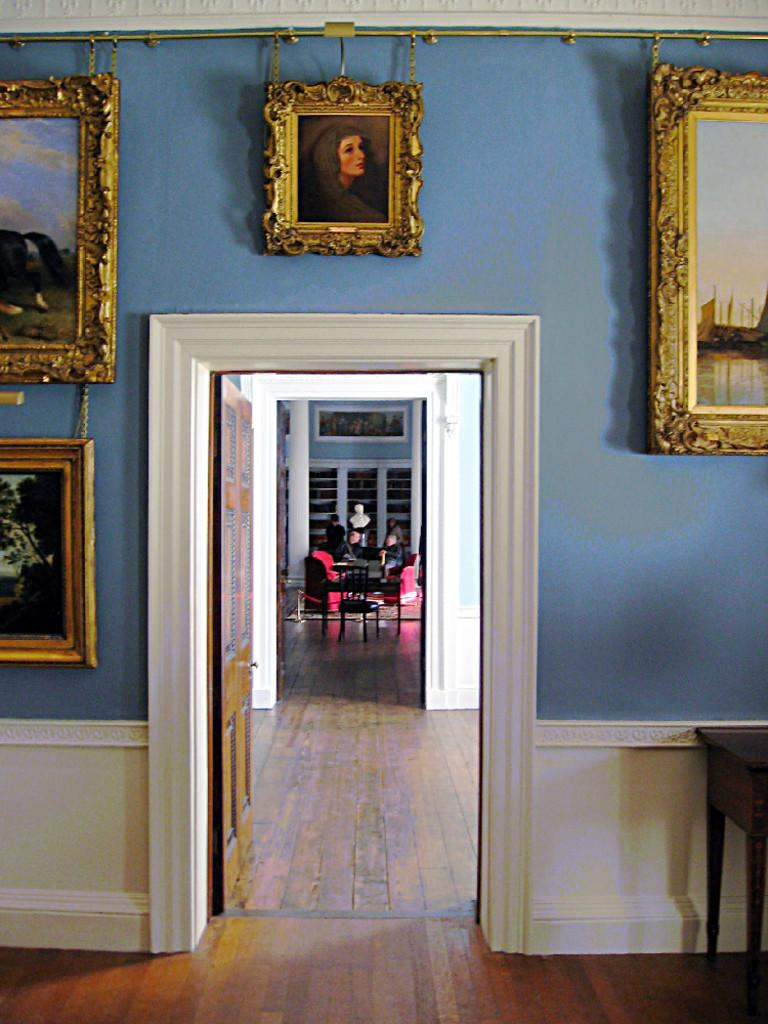What type of space is depicted in the image? The image shows an inner view of a room. What can be seen on the wall in the room? There are photo frames on the wall. What are the people in the room doing? There are people seated on chairs in the room. What is the taste of the argument between the people in the image? There is no argument depicted in the image; the people are simply seated on chairs. What subject is being taught by the person in the image? There is no person teaching a subject in the image; the people are seated on chairs. 